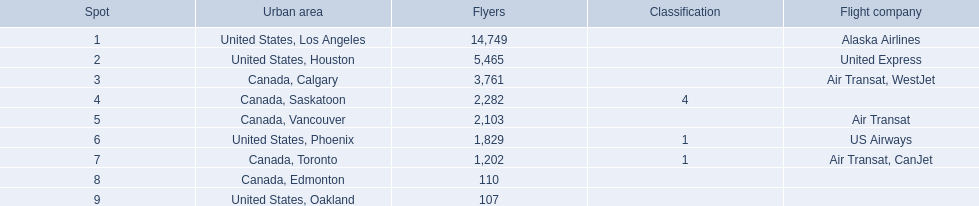What were all the passenger totals? 14,749, 5,465, 3,761, 2,282, 2,103, 1,829, 1,202, 110, 107. Which of these were to los angeles? 14,749. What other destination combined with this is closest to 19,000? Canada, Calgary. 